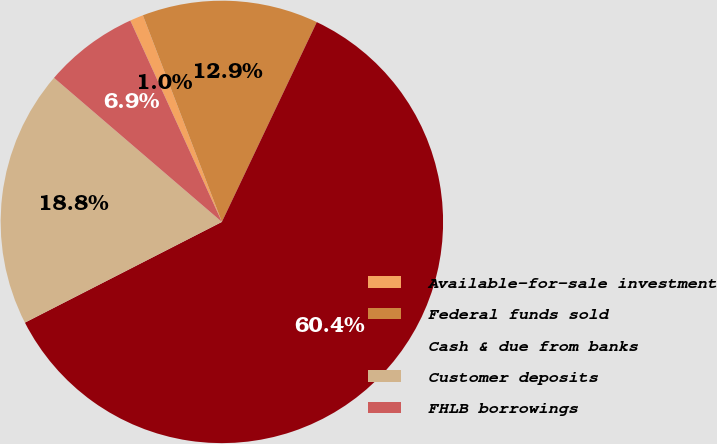Convert chart. <chart><loc_0><loc_0><loc_500><loc_500><pie_chart><fcel>Available-for-sale investment<fcel>Federal funds sold<fcel>Cash & due from banks<fcel>Customer deposits<fcel>FHLB borrowings<nl><fcel>0.98%<fcel>12.87%<fcel>60.42%<fcel>18.81%<fcel>6.92%<nl></chart> 